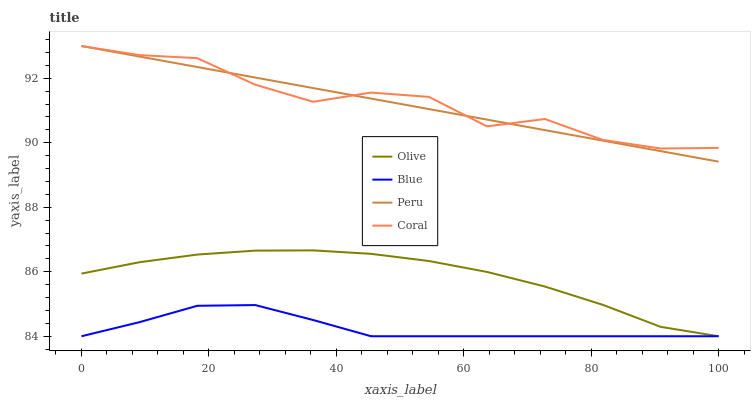Does Blue have the minimum area under the curve?
Answer yes or no. Yes. Does Coral have the maximum area under the curve?
Answer yes or no. Yes. Does Coral have the minimum area under the curve?
Answer yes or no. No. Does Blue have the maximum area under the curve?
Answer yes or no. No. Is Peru the smoothest?
Answer yes or no. Yes. Is Coral the roughest?
Answer yes or no. Yes. Is Blue the smoothest?
Answer yes or no. No. Is Blue the roughest?
Answer yes or no. No. Does Olive have the lowest value?
Answer yes or no. Yes. Does Coral have the lowest value?
Answer yes or no. No. Does Peru have the highest value?
Answer yes or no. Yes. Does Blue have the highest value?
Answer yes or no. No. Is Blue less than Peru?
Answer yes or no. Yes. Is Peru greater than Blue?
Answer yes or no. Yes. Does Olive intersect Blue?
Answer yes or no. Yes. Is Olive less than Blue?
Answer yes or no. No. Is Olive greater than Blue?
Answer yes or no. No. Does Blue intersect Peru?
Answer yes or no. No. 